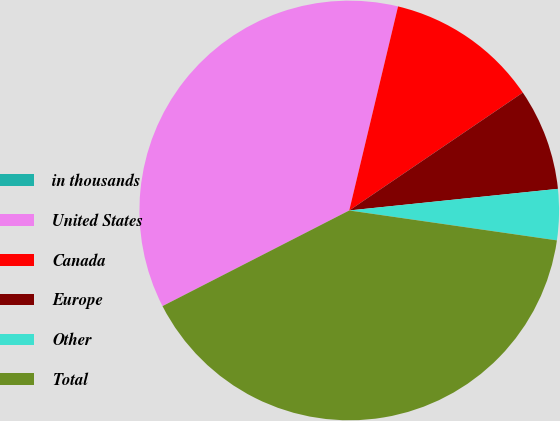Convert chart to OTSL. <chart><loc_0><loc_0><loc_500><loc_500><pie_chart><fcel>in thousands<fcel>United States<fcel>Canada<fcel>Europe<fcel>Other<fcel>Total<nl><fcel>0.0%<fcel>36.27%<fcel>11.77%<fcel>7.85%<fcel>3.92%<fcel>40.19%<nl></chart> 